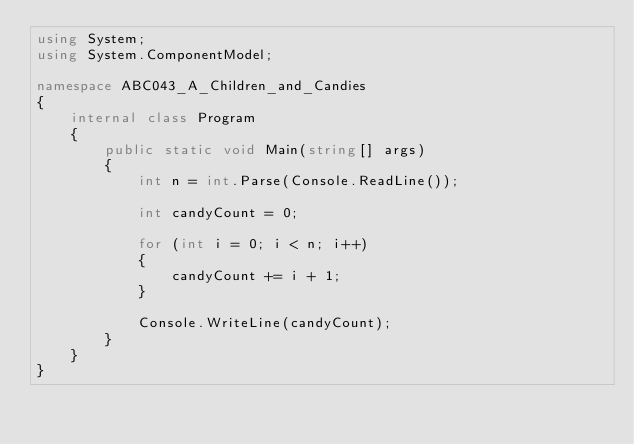Convert code to text. <code><loc_0><loc_0><loc_500><loc_500><_C#_>using System;
using System.ComponentModel;

namespace ABC043_A_Children_and_Candies
{
	internal class Program
	{
		public static void Main(string[] args)
		{
			int n = int.Parse(Console.ReadLine());

			int candyCount = 0;

			for (int i = 0; i < n; i++)
			{
				candyCount += i + 1;
			}
			
			Console.WriteLine(candyCount);
		}
	}
}</code> 